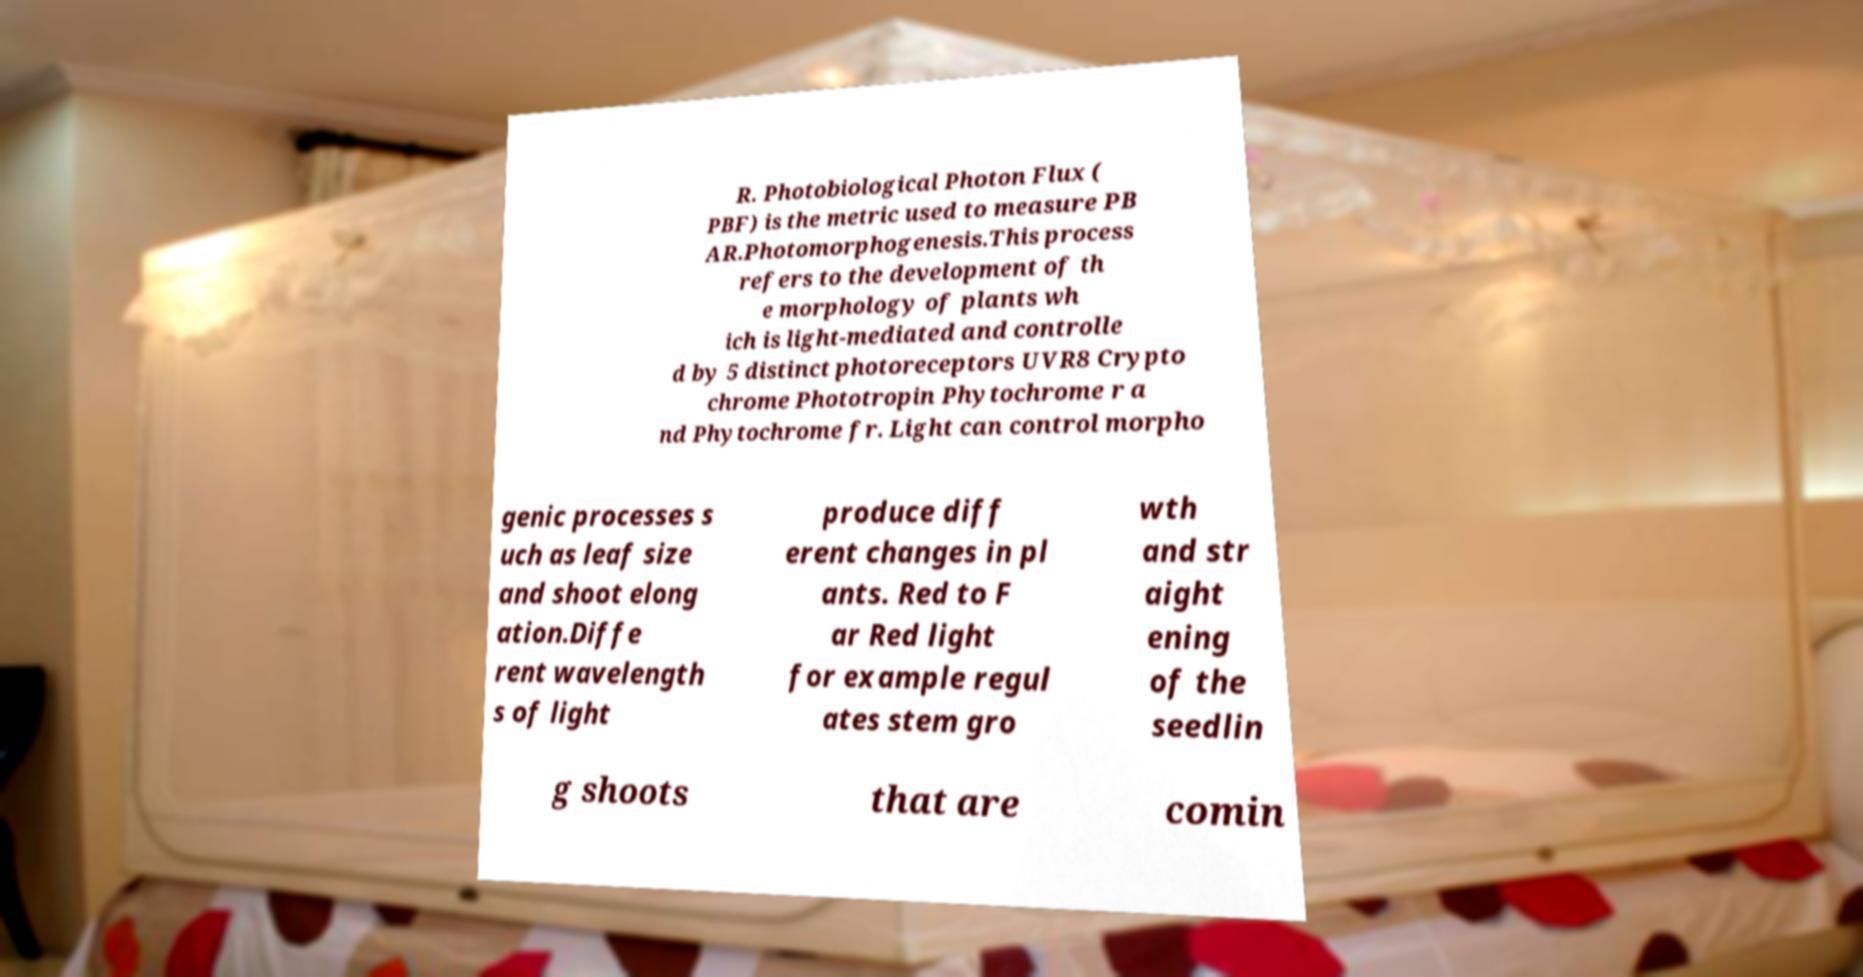Please read and relay the text visible in this image. What does it say? R. Photobiological Photon Flux ( PBF) is the metric used to measure PB AR.Photomorphogenesis.This process refers to the development of th e morphology of plants wh ich is light-mediated and controlle d by 5 distinct photoreceptors UVR8 Crypto chrome Phototropin Phytochrome r a nd Phytochrome fr. Light can control morpho genic processes s uch as leaf size and shoot elong ation.Diffe rent wavelength s of light produce diff erent changes in pl ants. Red to F ar Red light for example regul ates stem gro wth and str aight ening of the seedlin g shoots that are comin 